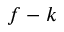<formula> <loc_0><loc_0><loc_500><loc_500>f - k</formula> 